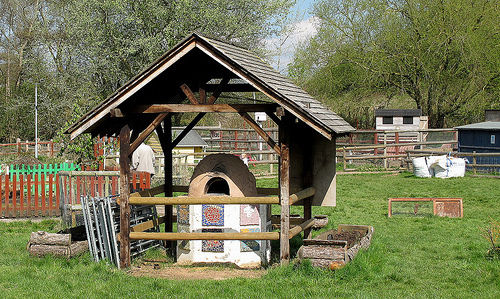<image>
Can you confirm if the hut is in front of the man? Yes. The hut is positioned in front of the man, appearing closer to the camera viewpoint. 